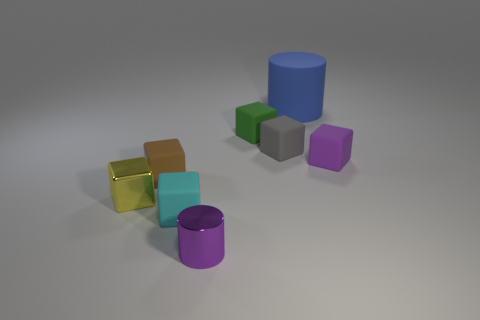The other metallic thing that is the same shape as the tiny cyan object is what color?
Keep it short and to the point. Yellow. How many tiny green objects are right of the tiny purple object that is to the right of the tiny purple thing in front of the brown matte block?
Offer a terse response. 0. Is there anything else that is the same color as the small metal cube?
Give a very brief answer. No. Do the small rubber thing that is right of the gray rubber cube and the cylinder behind the green matte thing have the same color?
Offer a terse response. No. Is the number of cyan matte things right of the small green rubber object greater than the number of tiny metallic cubes that are in front of the cyan block?
Your response must be concise. No. What material is the tiny cylinder?
Ensure brevity in your answer.  Metal. There is a small metallic thing that is behind the small purple cylinder on the left side of the rubber cylinder to the left of the tiny purple matte thing; what shape is it?
Offer a terse response. Cube. What number of other objects are the same material as the cyan object?
Keep it short and to the point. 5. Is the cylinder in front of the tiny purple matte thing made of the same material as the purple object right of the rubber cylinder?
Give a very brief answer. No. What number of tiny cubes are on the right side of the tiny gray matte thing and in front of the small yellow shiny block?
Your response must be concise. 0. 